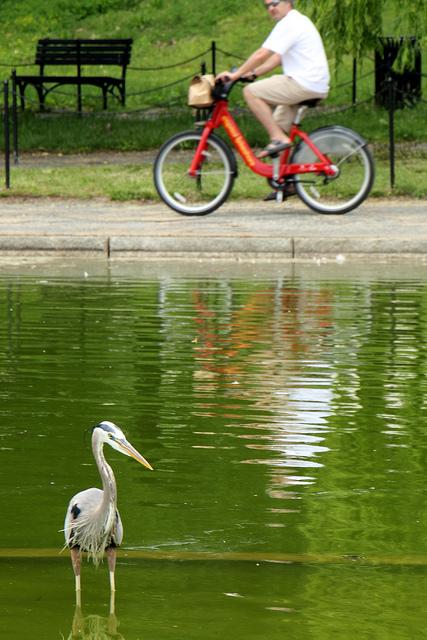At What location is the biker riding by the bird? park 